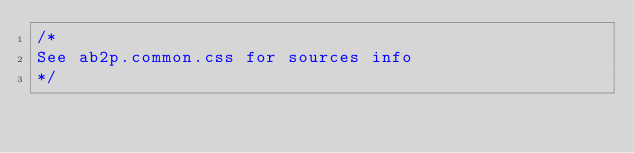Convert code to text. <code><loc_0><loc_0><loc_500><loc_500><_CSS_>/*
See ab2p.common.css for sources info
*/</code> 